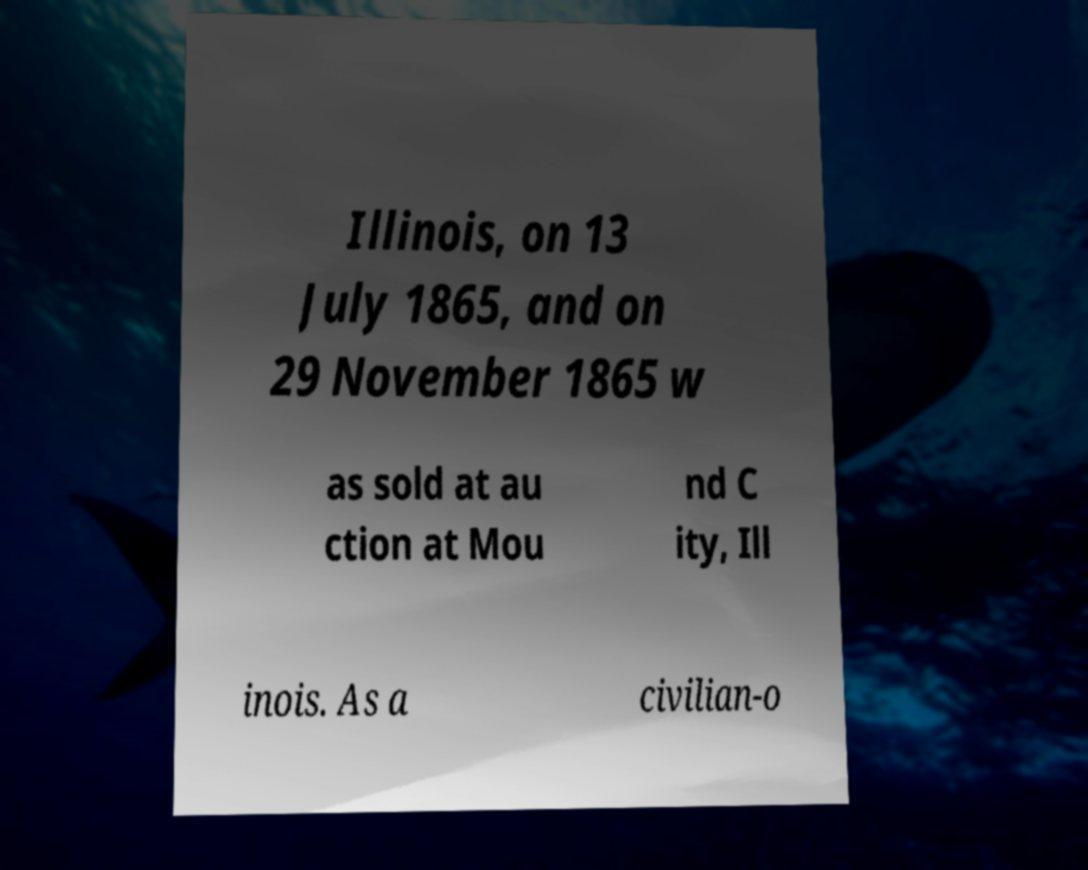There's text embedded in this image that I need extracted. Can you transcribe it verbatim? Illinois, on 13 July 1865, and on 29 November 1865 w as sold at au ction at Mou nd C ity, Ill inois. As a civilian-o 